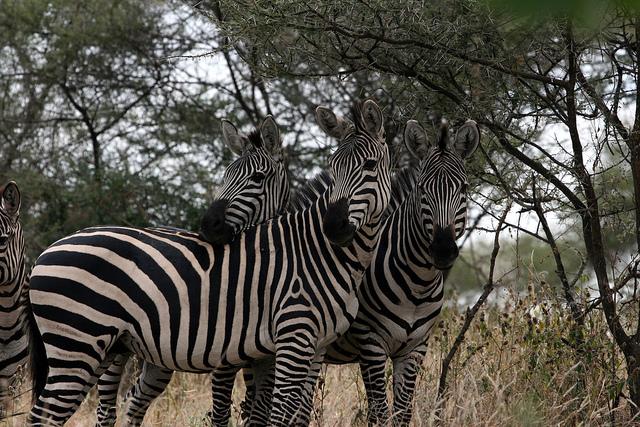Could the middle zebra be irritated?
Give a very brief answer. Yes. Is this a zoo?
Give a very brief answer. No. Is this zebra looking at the camera?
Short answer required. Yes. What are the zebras looking for?
Quick response, please. Food. How many zebras are in the picture?
Be succinct. 3. Is this the zebra's natural habitat?
Keep it brief. Yes. Are animals in the picture of the same species?
Keep it brief. Yes. Is the zebra alone?
Write a very short answer. No. How many zebras are there?
Be succinct. 4. Where are the animals looking?
Short answer required. At camera. How many zebras?
Be succinct. 4. How many animals are in the pic?
Keep it brief. 4. Are the zebras facing away from the camera?
Give a very brief answer. No. How many adult animals can be seen?
Answer briefly. 3. What continent was this picture most likely taken on?
Keep it brief. Africa. 